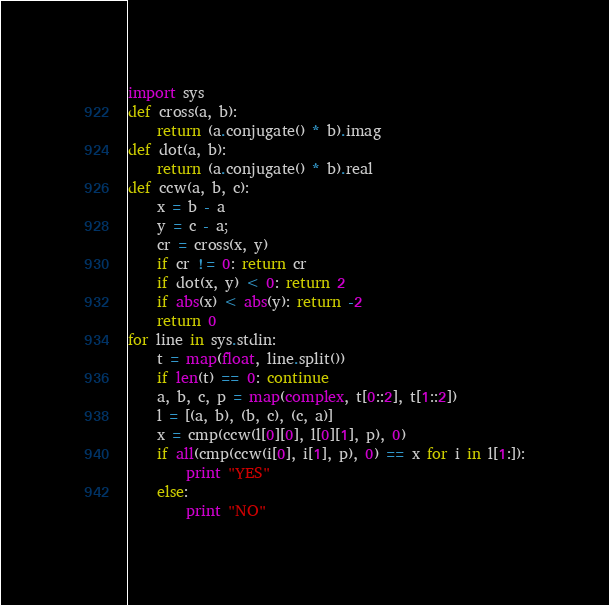<code> <loc_0><loc_0><loc_500><loc_500><_Python_>import sys
def cross(a, b):
	return (a.conjugate() * b).imag
def dot(a, b):
	return (a.conjugate() * b).real
def ccw(a, b, c):
	x = b - a
	y = c - a;
	cr = cross(x, y)
	if cr != 0: return cr
	if dot(x, y) < 0: return 2
	if abs(x) < abs(y): return -2
	return 0
for line in sys.stdin:
	t = map(float, line.split())
	if len(t) == 0: continue
	a, b, c, p = map(complex, t[0::2], t[1::2])
	l = [(a, b), (b, c), (c, a)]
	x = cmp(ccw(l[0][0], l[0][1], p), 0)
	if all(cmp(ccw(i[0], i[1], p), 0) == x for i in l[1:]):
		print "YES"
	else:
		print "NO"</code> 